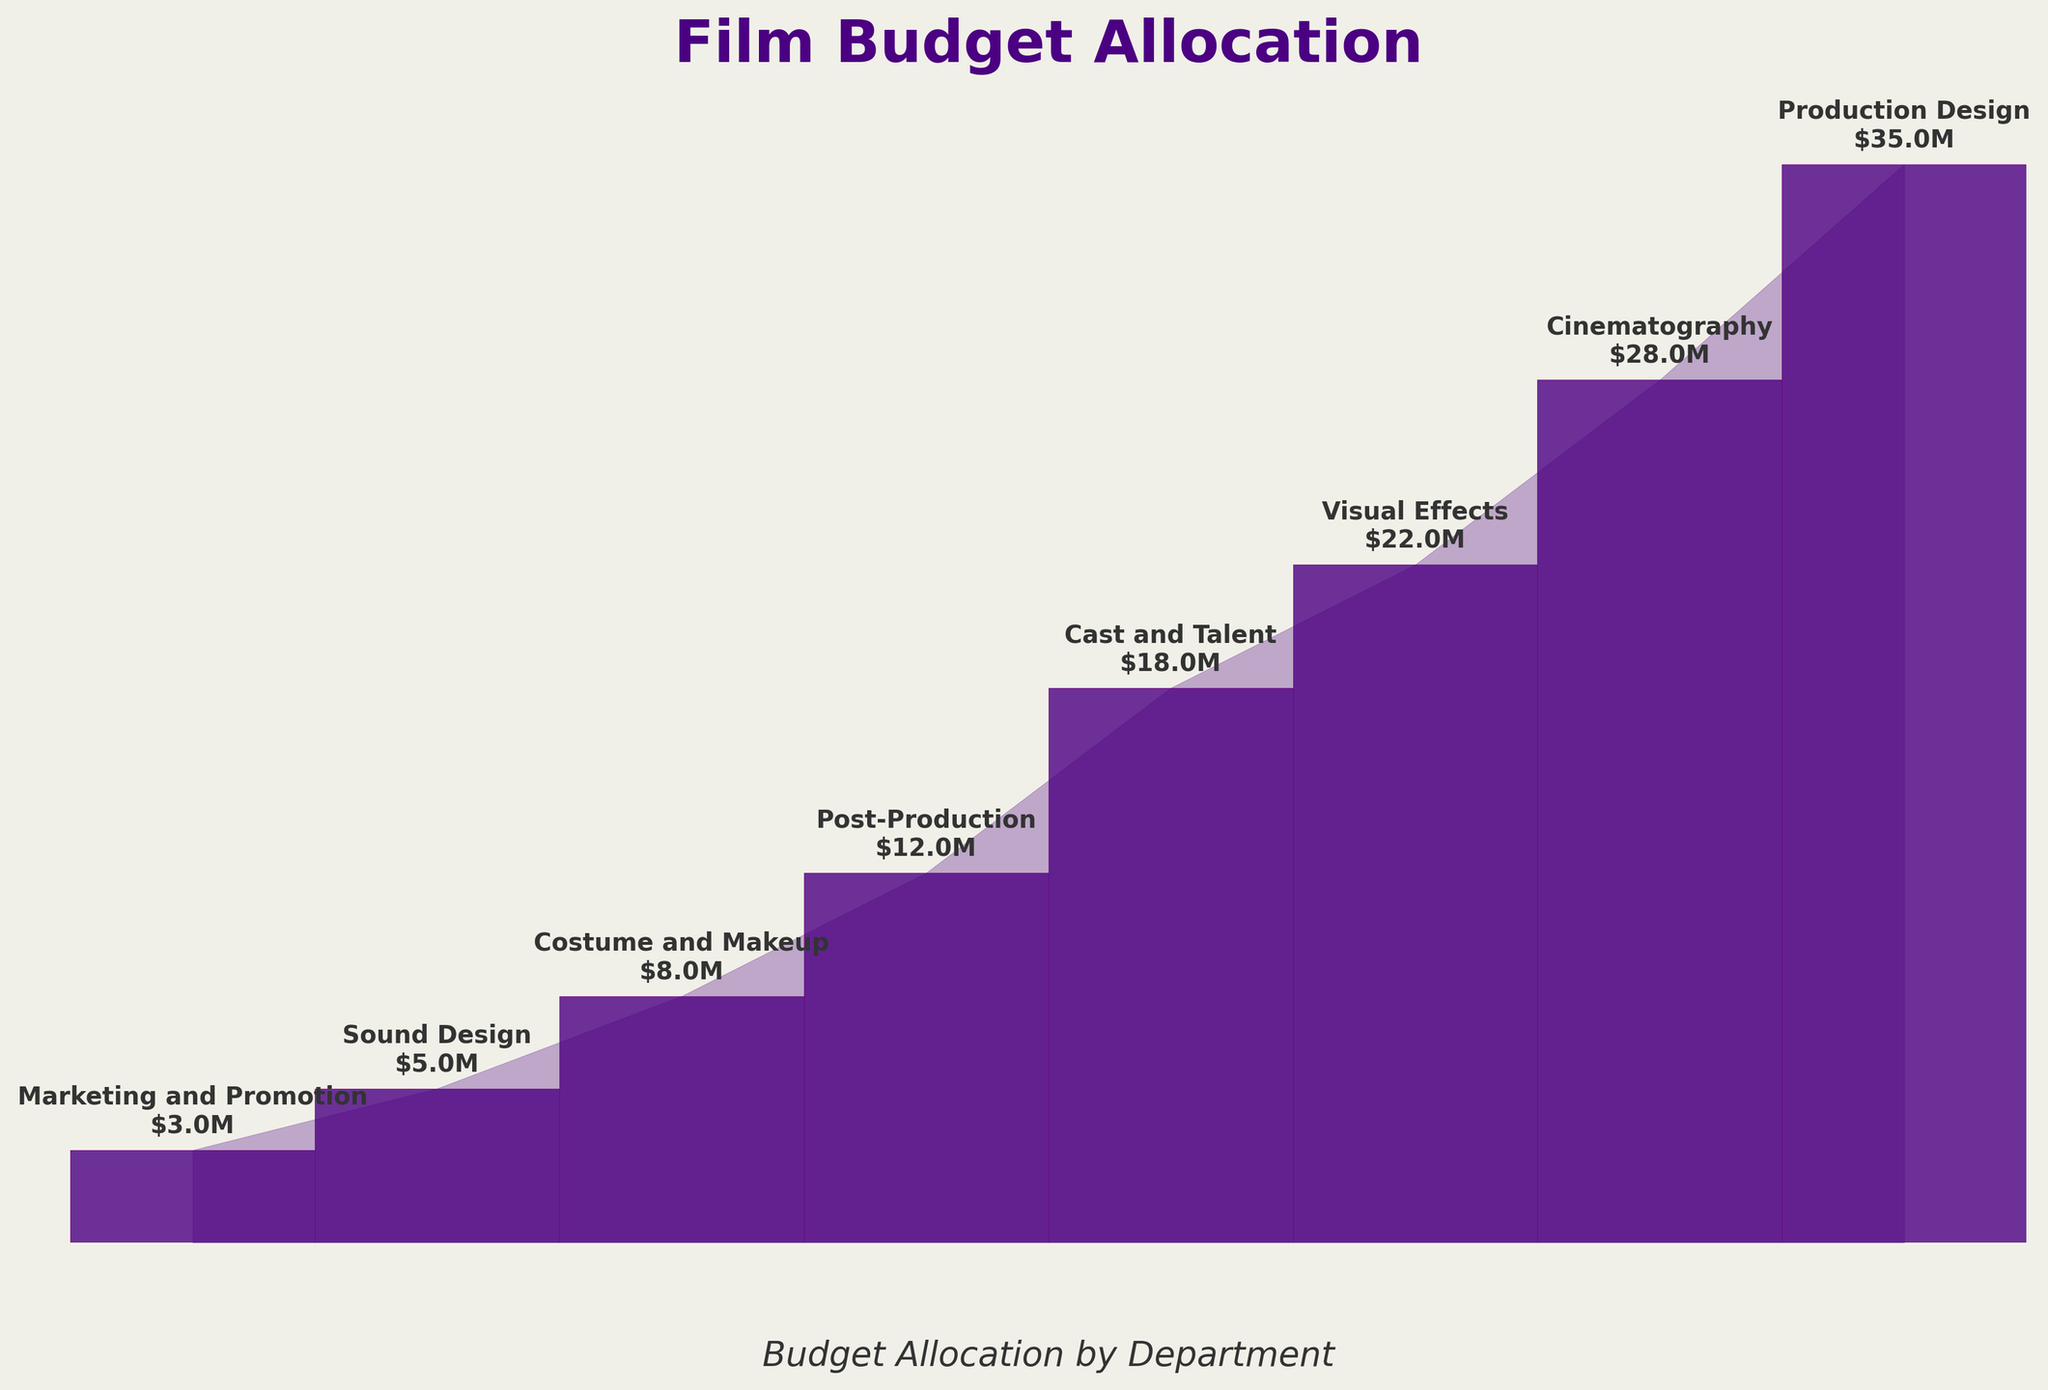What's the title of the figure? The title of the figure is displayed at the top in large, bold font. It helps to quickly identify the subject of the visualization.
Answer: "Film Budget Allocation" How many departments are included in the chart? By counting the distinct labels on the bars from top to bottom, we can determine the number of departments.
Answer: 8 What department has the highest budget allocation? By looking at the longest bar at the top of the funnel chart, labeled accordingly, we can identify the department with the highest allocation.
Answer: Production Design What is the combined budget of Post-Production and Costume and Makeup? To find the combined budget, we add the individual budget values of Post-Production ($12 million) and Costume and Makeup ($8 million). $12M + $8M = $20M.
Answer: $20 million Which department has a lower budget allocation: Visual Effects or Cast and Talent? By comparing the lengths of the bars and their corresponding labels, Visual Effects and Cast and Talent, we see that Cast and Talent has a shorter bar.
Answer: Cast and Talent What is the difference in budget allocation between Production Design and Sound Design? Subtract the budget of Sound Design ($5 million) from that of Production Design ($35 million). $35M - $5M = $30M.
Answer: $30 million How does the budget for Marketing and Promotion compare to that of Cinematography? Looking at the chart, Marketing and Promotion has a significantly smaller allocation than Cinematography. Cinematography's bar is much longer.
Answer: Marketing and Promotion has a smaller budget Which two departments combined have a total budget closest to $50 million? Evaluate pairs of departments: (Production Design $35M + Cinematography $28M = $63M), (Visual Effects $22M + Cast and Talent $18M = $40M), (Post-Production $12M + Costume and Makeup $8M = $20M), (Production Design $35M + Costume and Makeup $8M = $43M), etc. The pair Production Design ($35M) and Sound Design ($5M) adds up to $40M, which is closest among given pairs.
Answer: Production Design and Sound Design What percentage of the total budget is allocated to Visual Effects? To find the percentage, divide the budget for Visual Effects ($22 million) by the total budget and multiply by 100. Total budget: $35M+$28M+$22M+$18M+$12M+$8M+$5M+$3M = $131M. ($22M / $131M) * 100 ≈ 16.8%.
Answer: 16.8% Which three departments have the lowest budget allocations? By inspecting the three shortest bars (in ascending order visually), we find these departments are Marketing and Promotion, Sound Design, and Costume and Makeup.
Answer: Marketing and Promotion, Sound Design, and Costume and Makeup 